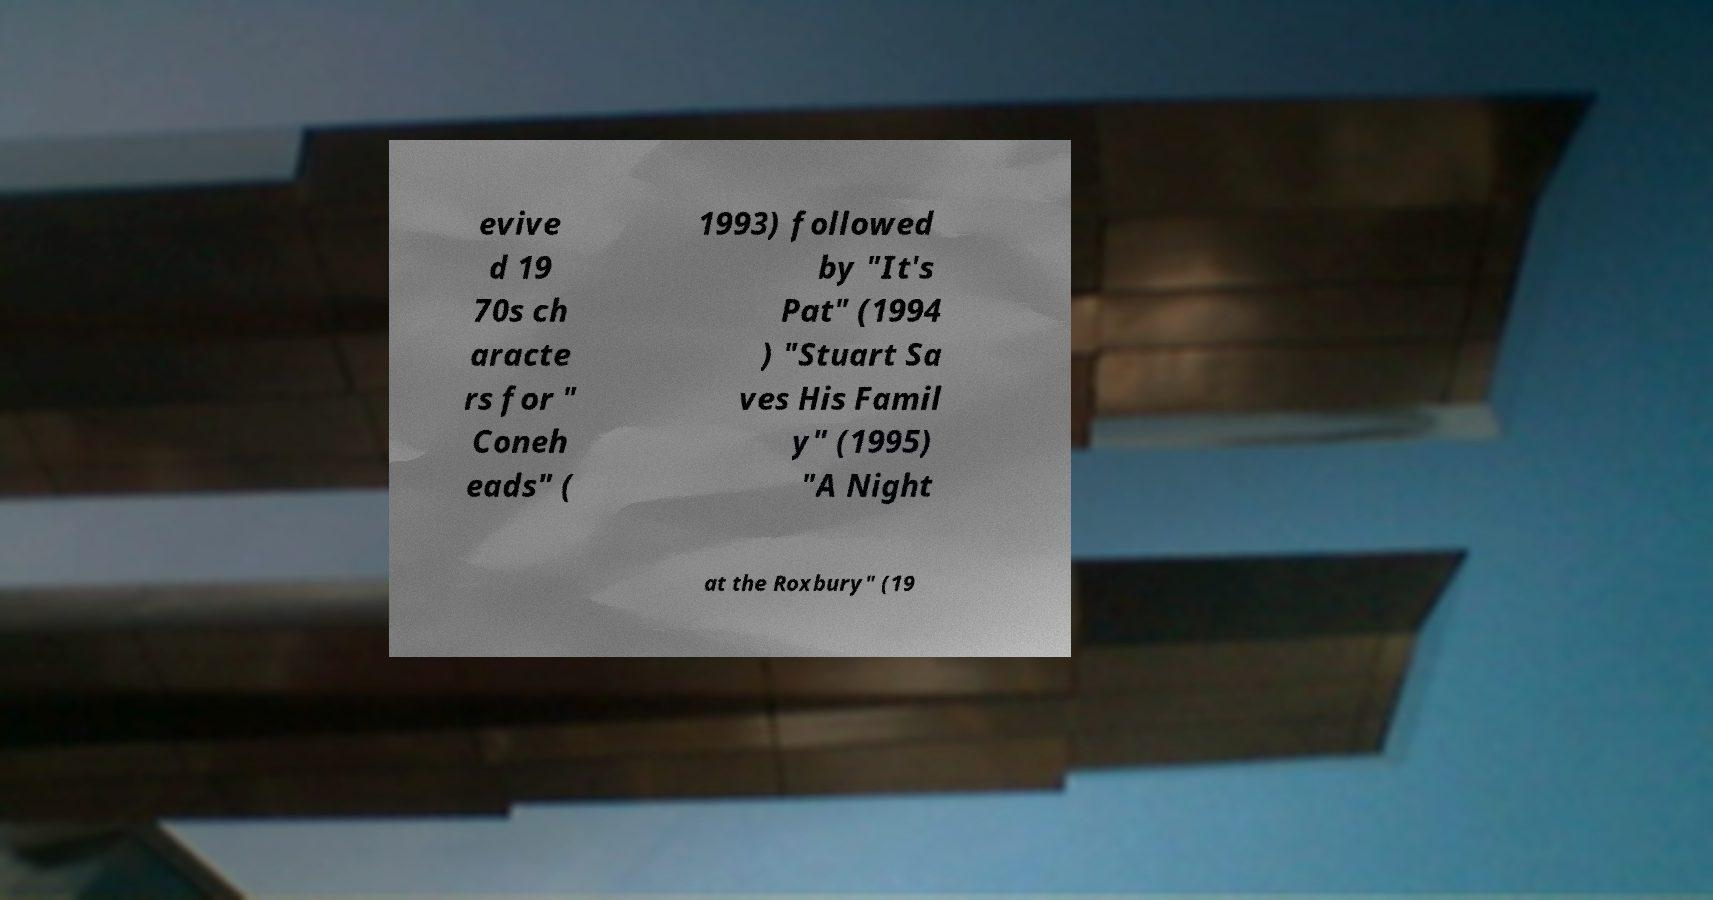There's text embedded in this image that I need extracted. Can you transcribe it verbatim? evive d 19 70s ch aracte rs for " Coneh eads" ( 1993) followed by "It's Pat" (1994 ) "Stuart Sa ves His Famil y" (1995) "A Night at the Roxbury" (19 